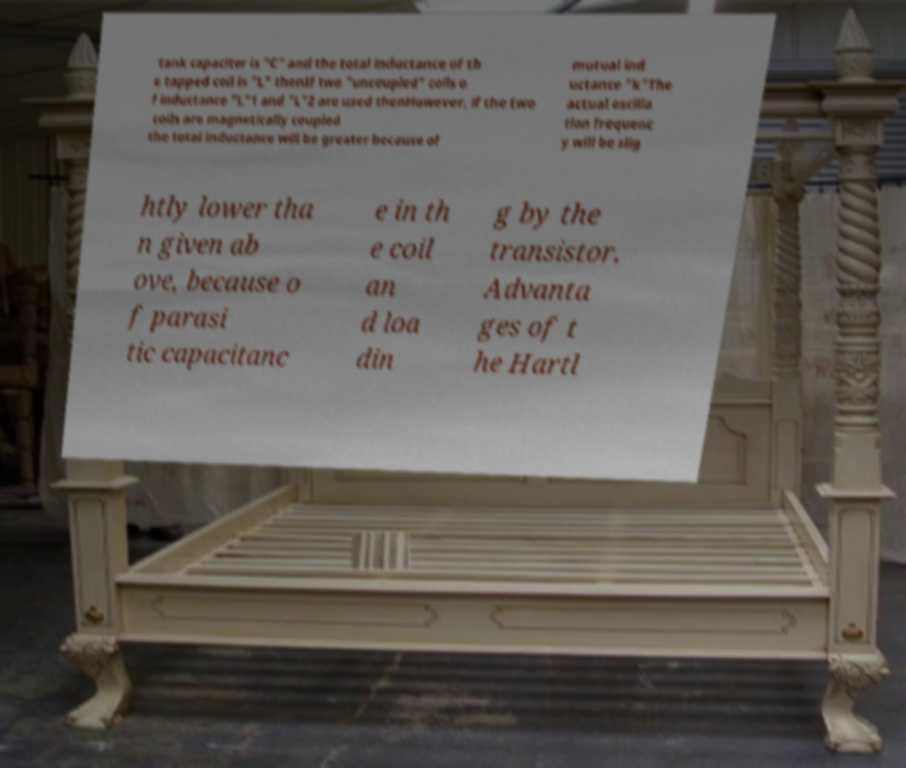Can you read and provide the text displayed in the image?This photo seems to have some interesting text. Can you extract and type it out for me? tank capacitor is "C" and the total inductance of th e tapped coil is "L" thenIf two "uncoupled" coils o f inductance "L"1 and "L"2 are used thenHowever, if the two coils are magnetically coupled the total inductance will be greater because of mutual ind uctance "k"The actual oscilla tion frequenc y will be slig htly lower tha n given ab ove, because o f parasi tic capacitanc e in th e coil an d loa din g by the transistor. Advanta ges of t he Hartl 